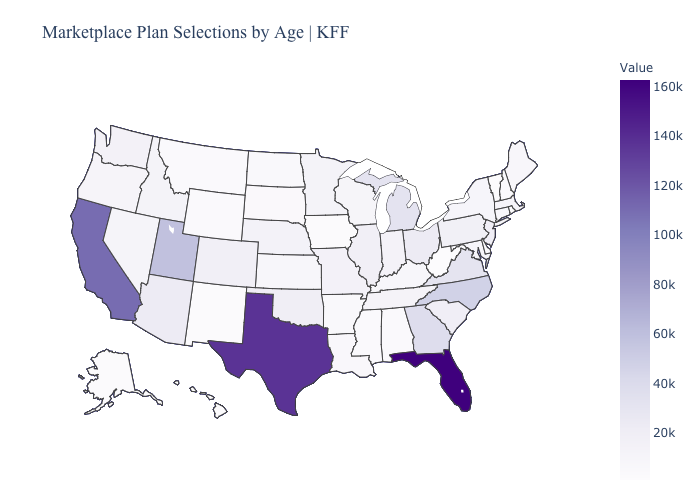Among the states that border Ohio , which have the lowest value?
Answer briefly. West Virginia. Does the map have missing data?
Quick response, please. No. Which states have the lowest value in the USA?
Concise answer only. West Virginia. Does New Hampshire have a lower value than Virginia?
Keep it brief. Yes. Which states have the lowest value in the West?
Be succinct. Hawaii. 